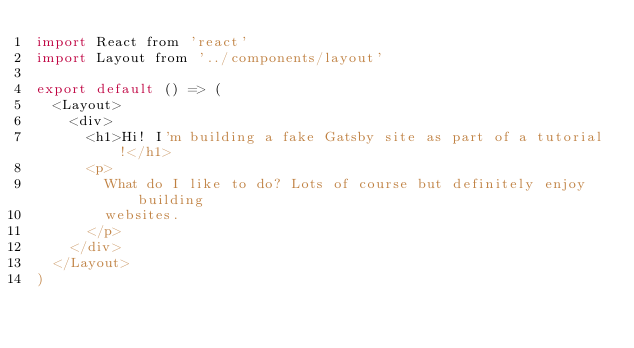<code> <loc_0><loc_0><loc_500><loc_500><_JavaScript_>import React from 'react'
import Layout from '../components/layout'

export default () => (
  <Layout>
    <div>
      <h1>Hi! I'm building a fake Gatsby site as part of a tutorial!</h1>
      <p>
        What do I like to do? Lots of course but definitely enjoy building
        websites.
      </p>
    </div>
  </Layout>
)
</code> 